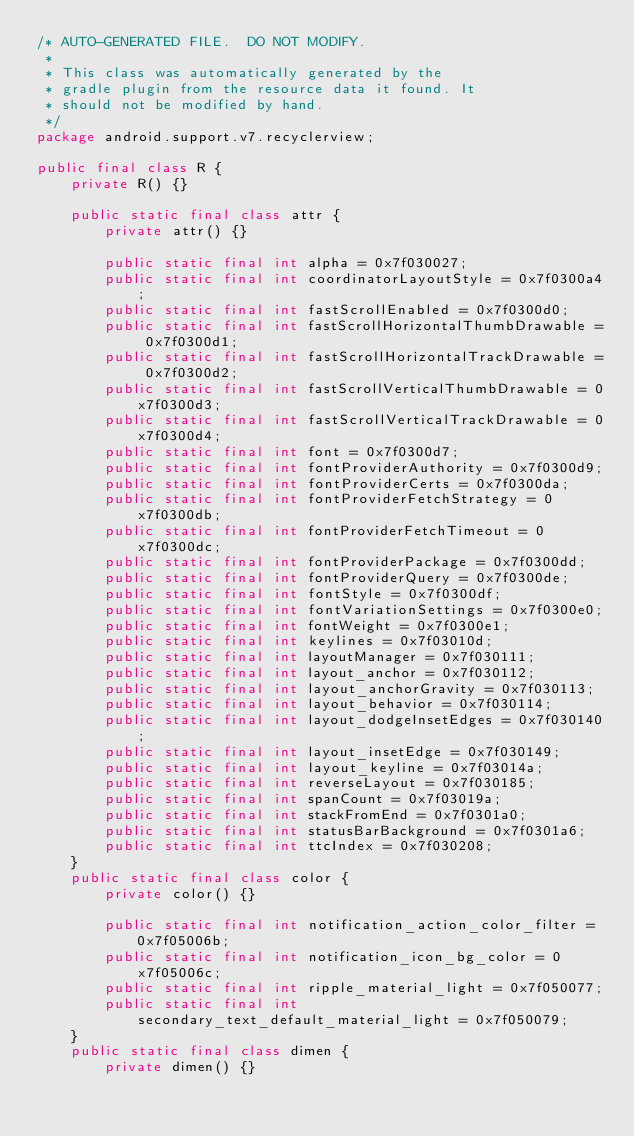Convert code to text. <code><loc_0><loc_0><loc_500><loc_500><_Java_>/* AUTO-GENERATED FILE.  DO NOT MODIFY.
 *
 * This class was automatically generated by the
 * gradle plugin from the resource data it found. It
 * should not be modified by hand.
 */
package android.support.v7.recyclerview;

public final class R {
    private R() {}

    public static final class attr {
        private attr() {}

        public static final int alpha = 0x7f030027;
        public static final int coordinatorLayoutStyle = 0x7f0300a4;
        public static final int fastScrollEnabled = 0x7f0300d0;
        public static final int fastScrollHorizontalThumbDrawable = 0x7f0300d1;
        public static final int fastScrollHorizontalTrackDrawable = 0x7f0300d2;
        public static final int fastScrollVerticalThumbDrawable = 0x7f0300d3;
        public static final int fastScrollVerticalTrackDrawable = 0x7f0300d4;
        public static final int font = 0x7f0300d7;
        public static final int fontProviderAuthority = 0x7f0300d9;
        public static final int fontProviderCerts = 0x7f0300da;
        public static final int fontProviderFetchStrategy = 0x7f0300db;
        public static final int fontProviderFetchTimeout = 0x7f0300dc;
        public static final int fontProviderPackage = 0x7f0300dd;
        public static final int fontProviderQuery = 0x7f0300de;
        public static final int fontStyle = 0x7f0300df;
        public static final int fontVariationSettings = 0x7f0300e0;
        public static final int fontWeight = 0x7f0300e1;
        public static final int keylines = 0x7f03010d;
        public static final int layoutManager = 0x7f030111;
        public static final int layout_anchor = 0x7f030112;
        public static final int layout_anchorGravity = 0x7f030113;
        public static final int layout_behavior = 0x7f030114;
        public static final int layout_dodgeInsetEdges = 0x7f030140;
        public static final int layout_insetEdge = 0x7f030149;
        public static final int layout_keyline = 0x7f03014a;
        public static final int reverseLayout = 0x7f030185;
        public static final int spanCount = 0x7f03019a;
        public static final int stackFromEnd = 0x7f0301a0;
        public static final int statusBarBackground = 0x7f0301a6;
        public static final int ttcIndex = 0x7f030208;
    }
    public static final class color {
        private color() {}

        public static final int notification_action_color_filter = 0x7f05006b;
        public static final int notification_icon_bg_color = 0x7f05006c;
        public static final int ripple_material_light = 0x7f050077;
        public static final int secondary_text_default_material_light = 0x7f050079;
    }
    public static final class dimen {
        private dimen() {}
</code> 